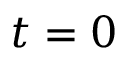Convert formula to latex. <formula><loc_0><loc_0><loc_500><loc_500>t = 0</formula> 